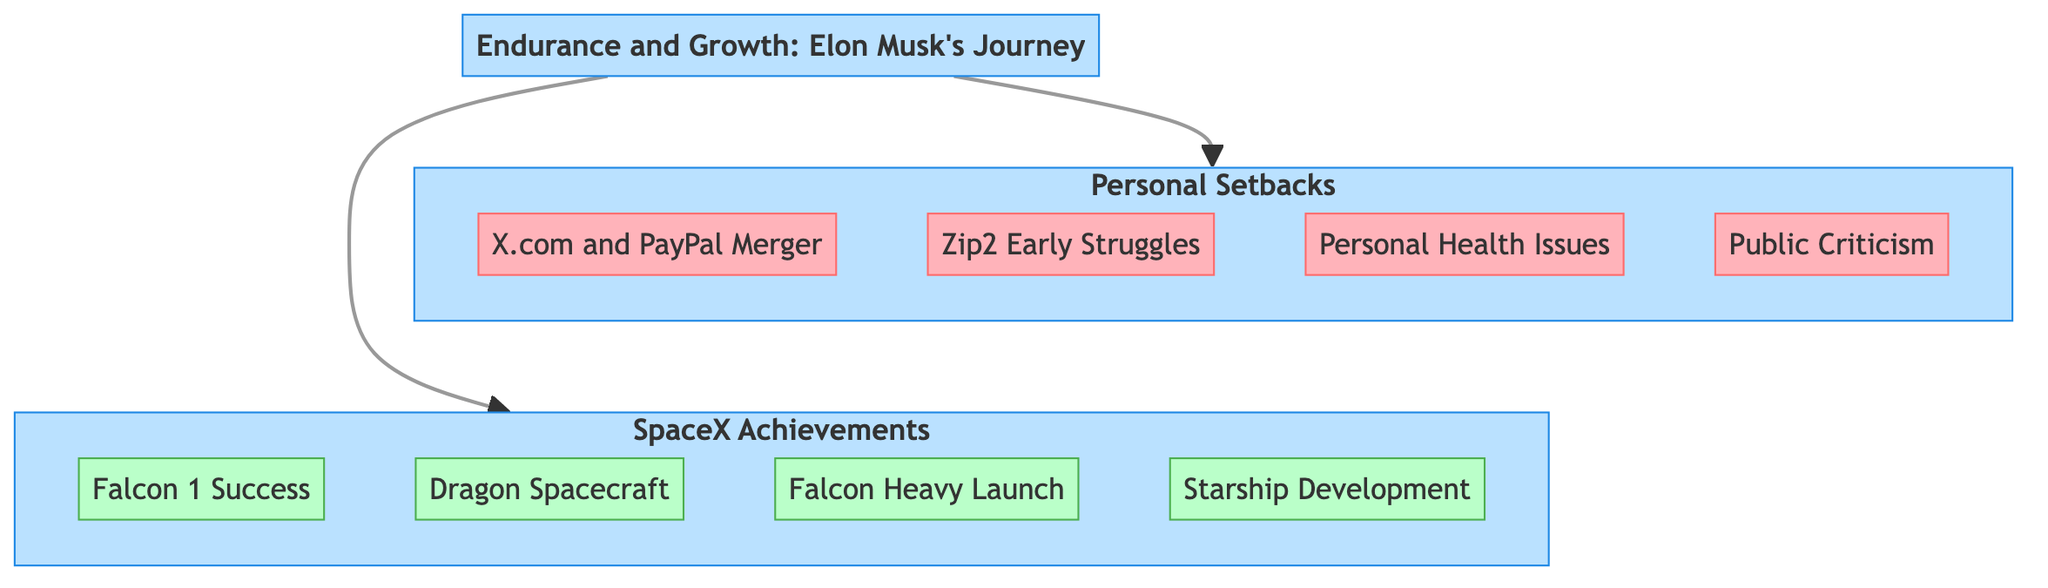What are the two main categories in the diagram? The diagram presents two main categories: Personal Setbacks and SpaceX Achievements, which are displayed as separate sections connected to the title.
Answer: Personal Setbacks, SpaceX Achievements How many personal setbacks are listed in the diagram? The diagram shows a total of four personal setbacks listed under the Personal Setbacks category, each represented as a separate node.
Answer: 4 Which achievement comes after the Falcon 1 Success? The diagram indicates the sequence within the SpaceX Achievements category where the Dragon Spacecraft is listed immediately after the Falcon 1 Success accomplishment.
Answer: Dragon Spacecraft What type of challenges were faced during the X.com and PayPal merger? The diagram specifies that significant challenges and management issues were encountered, represented in the description of the X.com and PayPal Merger node.
Answer: Management issues How does the number of SpaceX Achievements compare to Personal Setbacks? By counting the nodes, the diagram reveals that there are four SpaceX achievements, while there are only four personal setbacks, leading to an equal count.
Answer: Equal (4 each) What is the significance of the link style in the diagram? The link style is set to a default configuration with specific properties such as stroke-width and fill, connecting the categories and enhancing the visual flow of the information.
Answer: Visual clarity Which achievement represents a significant technical milestone in 2018? The diagram highlights the Falcon Heavy Launch as the notable achievement that occurred in 2018, showcasing its significance in the timeline of SpaceX achievements.
Answer: Falcon Heavy Launch What was a common theme in Musk's personal setbacks? The diagram illustrates that a common theme among Musk's personal setbacks relates to public scrutiny, seen in the description of the Public Criticism node.
Answer: Public scrutiny 